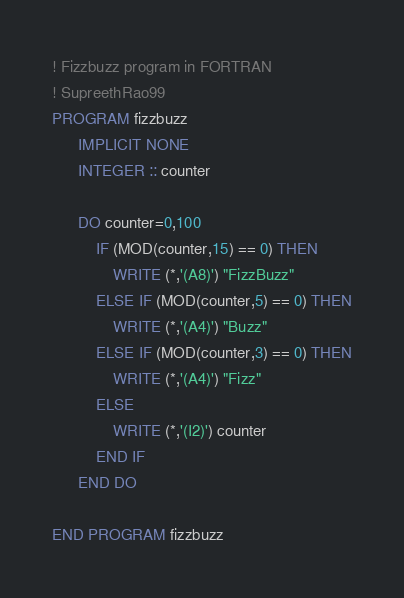Convert code to text. <code><loc_0><loc_0><loc_500><loc_500><_FORTRAN_>! Fizzbuzz program in FORTRAN
! SupreethRao99
PROGRAM fizzbuzz
      IMPLICIT NONE
      INTEGER :: counter 
      
      DO counter=0,100
          IF (MOD(counter,15) == 0) THEN
              WRITE (*,'(A8)') "FizzBuzz"
          ELSE IF (MOD(counter,5) == 0) THEN
              WRITE (*,'(A4)') "Buzz"
          ELSE IF (MOD(counter,3) == 0) THEN
              WRITE (*,'(A4)') "Fizz"
          ELSE 
              WRITE (*,'(I2)') counter
          END IF
      END DO

END PROGRAM fizzbuzz</code> 